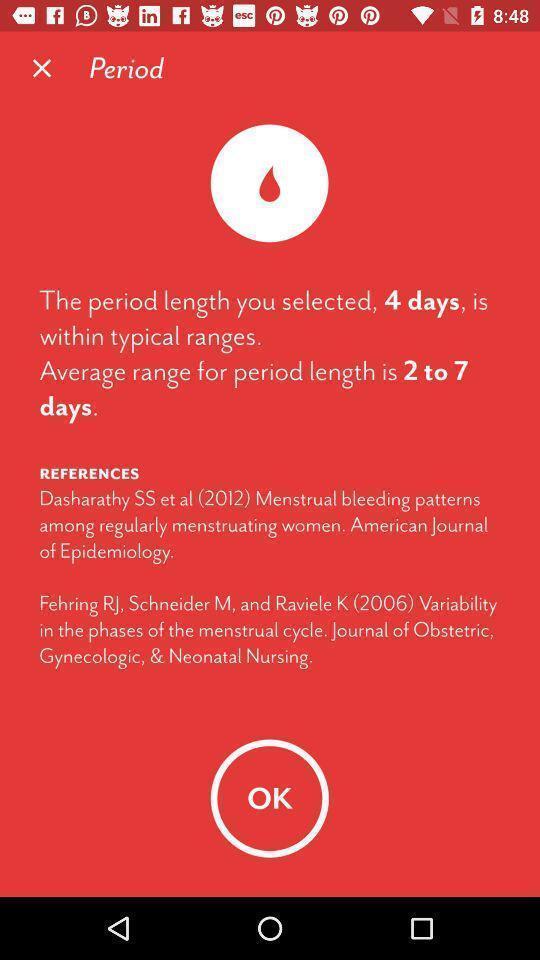What can you discern from this picture? Screen displaying information about menstrual period. 